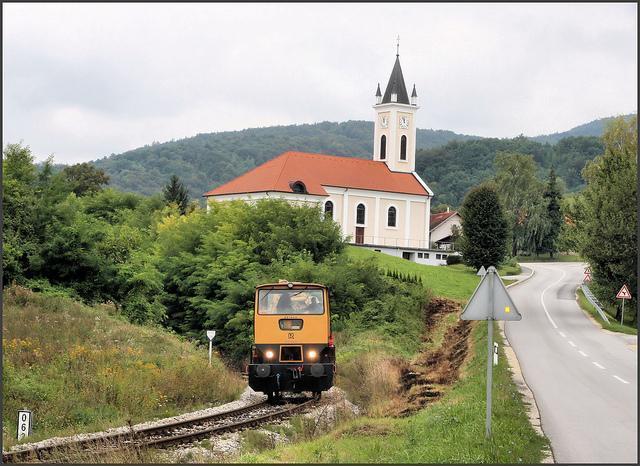What period of the day is shown here?
Indicate the correct choice and explain in the format: 'Answer: answer
Rationale: rationale.'
Options: Afternoon, evening, early morning, almost noon. Answer: almost noon.
Rationale: It is almost noon. 